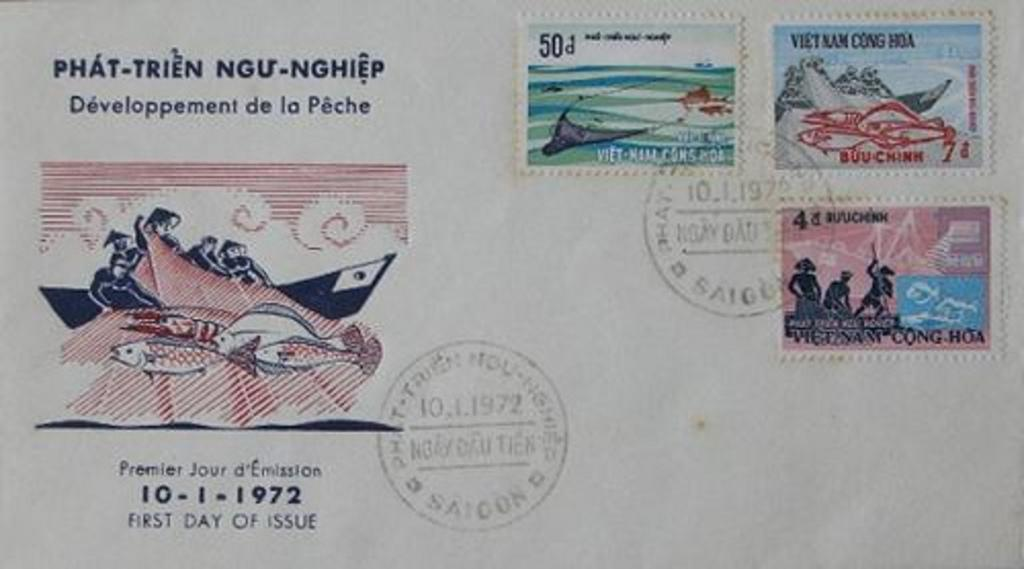Provide a one-sentence caption for the provided image. A postcard with stamps one labeled Vietnam Cong HDA  was sent in 1972. 